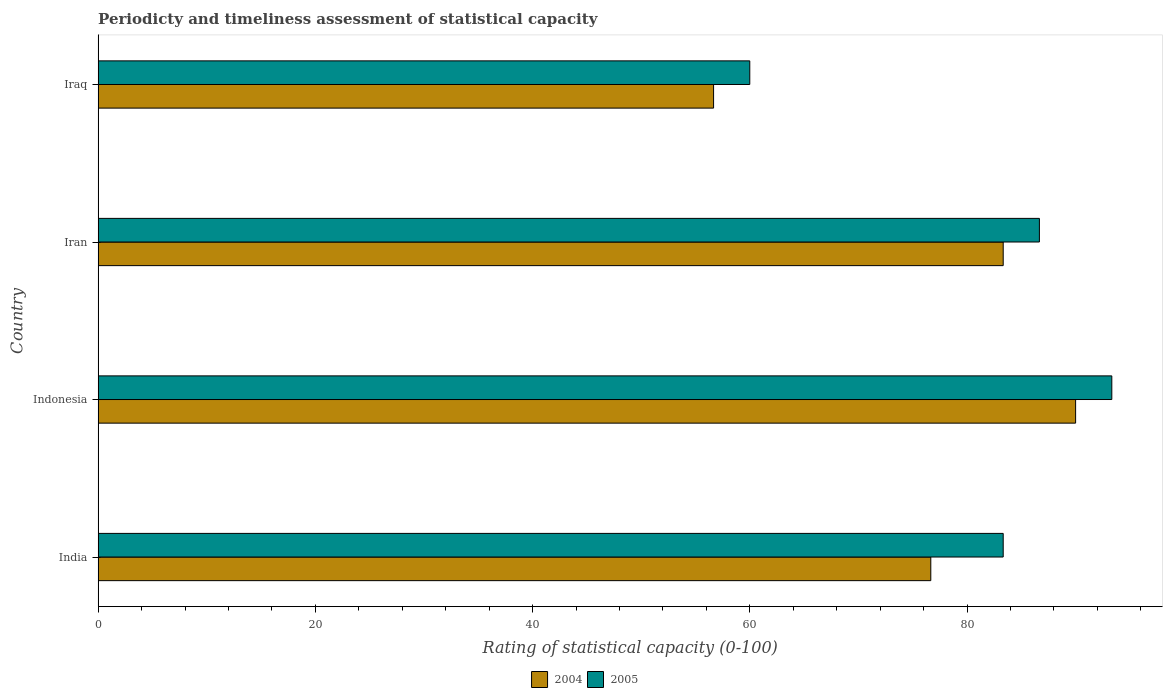How many groups of bars are there?
Your response must be concise. 4. Are the number of bars per tick equal to the number of legend labels?
Give a very brief answer. Yes. What is the label of the 2nd group of bars from the top?
Provide a succinct answer. Iran. In how many cases, is the number of bars for a given country not equal to the number of legend labels?
Offer a terse response. 0. What is the rating of statistical capacity in 2004 in India?
Provide a succinct answer. 76.67. In which country was the rating of statistical capacity in 2004 minimum?
Your answer should be very brief. Iraq. What is the total rating of statistical capacity in 2004 in the graph?
Provide a short and direct response. 306.67. What is the difference between the rating of statistical capacity in 2004 in India and that in Iran?
Your answer should be compact. -6.67. What is the average rating of statistical capacity in 2004 per country?
Give a very brief answer. 76.67. What is the difference between the rating of statistical capacity in 2004 and rating of statistical capacity in 2005 in Iraq?
Your answer should be compact. -3.33. In how many countries, is the rating of statistical capacity in 2004 greater than 80 ?
Provide a succinct answer. 2. What is the ratio of the rating of statistical capacity in 2005 in Indonesia to that in Iraq?
Offer a very short reply. 1.56. Is the rating of statistical capacity in 2005 in India less than that in Iraq?
Your answer should be compact. No. Is the difference between the rating of statistical capacity in 2004 in Iran and Iraq greater than the difference between the rating of statistical capacity in 2005 in Iran and Iraq?
Your answer should be compact. No. What is the difference between the highest and the second highest rating of statistical capacity in 2005?
Ensure brevity in your answer.  6.67. What is the difference between the highest and the lowest rating of statistical capacity in 2005?
Your answer should be very brief. 33.33. Is the sum of the rating of statistical capacity in 2004 in India and Iran greater than the maximum rating of statistical capacity in 2005 across all countries?
Your response must be concise. Yes. What does the 1st bar from the bottom in India represents?
Provide a short and direct response. 2004. Are all the bars in the graph horizontal?
Give a very brief answer. Yes. How many countries are there in the graph?
Provide a short and direct response. 4. What is the difference between two consecutive major ticks on the X-axis?
Offer a very short reply. 20. Are the values on the major ticks of X-axis written in scientific E-notation?
Your response must be concise. No. Does the graph contain grids?
Your answer should be very brief. No. Where does the legend appear in the graph?
Ensure brevity in your answer.  Bottom center. How are the legend labels stacked?
Provide a short and direct response. Horizontal. What is the title of the graph?
Offer a terse response. Periodicty and timeliness assessment of statistical capacity. What is the label or title of the X-axis?
Provide a succinct answer. Rating of statistical capacity (0-100). What is the label or title of the Y-axis?
Ensure brevity in your answer.  Country. What is the Rating of statistical capacity (0-100) in 2004 in India?
Keep it short and to the point. 76.67. What is the Rating of statistical capacity (0-100) of 2005 in India?
Offer a terse response. 83.33. What is the Rating of statistical capacity (0-100) of 2005 in Indonesia?
Provide a short and direct response. 93.33. What is the Rating of statistical capacity (0-100) in 2004 in Iran?
Provide a short and direct response. 83.33. What is the Rating of statistical capacity (0-100) of 2005 in Iran?
Make the answer very short. 86.67. What is the Rating of statistical capacity (0-100) in 2004 in Iraq?
Your answer should be compact. 56.67. What is the Rating of statistical capacity (0-100) in 2005 in Iraq?
Make the answer very short. 60. Across all countries, what is the maximum Rating of statistical capacity (0-100) of 2004?
Ensure brevity in your answer.  90. Across all countries, what is the maximum Rating of statistical capacity (0-100) of 2005?
Provide a short and direct response. 93.33. Across all countries, what is the minimum Rating of statistical capacity (0-100) of 2004?
Make the answer very short. 56.67. Across all countries, what is the minimum Rating of statistical capacity (0-100) of 2005?
Give a very brief answer. 60. What is the total Rating of statistical capacity (0-100) of 2004 in the graph?
Offer a very short reply. 306.67. What is the total Rating of statistical capacity (0-100) of 2005 in the graph?
Provide a short and direct response. 323.33. What is the difference between the Rating of statistical capacity (0-100) in 2004 in India and that in Indonesia?
Your response must be concise. -13.33. What is the difference between the Rating of statistical capacity (0-100) of 2005 in India and that in Indonesia?
Make the answer very short. -10. What is the difference between the Rating of statistical capacity (0-100) of 2004 in India and that in Iran?
Make the answer very short. -6.67. What is the difference between the Rating of statistical capacity (0-100) in 2004 in India and that in Iraq?
Offer a terse response. 20. What is the difference between the Rating of statistical capacity (0-100) of 2005 in India and that in Iraq?
Provide a short and direct response. 23.33. What is the difference between the Rating of statistical capacity (0-100) in 2005 in Indonesia and that in Iran?
Make the answer very short. 6.67. What is the difference between the Rating of statistical capacity (0-100) in 2004 in Indonesia and that in Iraq?
Give a very brief answer. 33.33. What is the difference between the Rating of statistical capacity (0-100) of 2005 in Indonesia and that in Iraq?
Offer a terse response. 33.33. What is the difference between the Rating of statistical capacity (0-100) of 2004 in Iran and that in Iraq?
Your answer should be very brief. 26.67. What is the difference between the Rating of statistical capacity (0-100) of 2005 in Iran and that in Iraq?
Offer a very short reply. 26.67. What is the difference between the Rating of statistical capacity (0-100) in 2004 in India and the Rating of statistical capacity (0-100) in 2005 in Indonesia?
Your answer should be compact. -16.67. What is the difference between the Rating of statistical capacity (0-100) in 2004 in India and the Rating of statistical capacity (0-100) in 2005 in Iraq?
Your answer should be compact. 16.67. What is the difference between the Rating of statistical capacity (0-100) of 2004 in Indonesia and the Rating of statistical capacity (0-100) of 2005 in Iran?
Your answer should be compact. 3.33. What is the difference between the Rating of statistical capacity (0-100) in 2004 in Iran and the Rating of statistical capacity (0-100) in 2005 in Iraq?
Make the answer very short. 23.33. What is the average Rating of statistical capacity (0-100) in 2004 per country?
Offer a very short reply. 76.67. What is the average Rating of statistical capacity (0-100) in 2005 per country?
Offer a very short reply. 80.83. What is the difference between the Rating of statistical capacity (0-100) of 2004 and Rating of statistical capacity (0-100) of 2005 in India?
Give a very brief answer. -6.67. What is the difference between the Rating of statistical capacity (0-100) in 2004 and Rating of statistical capacity (0-100) in 2005 in Indonesia?
Ensure brevity in your answer.  -3.33. What is the ratio of the Rating of statistical capacity (0-100) in 2004 in India to that in Indonesia?
Keep it short and to the point. 0.85. What is the ratio of the Rating of statistical capacity (0-100) in 2005 in India to that in Indonesia?
Your answer should be compact. 0.89. What is the ratio of the Rating of statistical capacity (0-100) in 2005 in India to that in Iran?
Ensure brevity in your answer.  0.96. What is the ratio of the Rating of statistical capacity (0-100) in 2004 in India to that in Iraq?
Give a very brief answer. 1.35. What is the ratio of the Rating of statistical capacity (0-100) in 2005 in India to that in Iraq?
Make the answer very short. 1.39. What is the ratio of the Rating of statistical capacity (0-100) in 2004 in Indonesia to that in Iran?
Make the answer very short. 1.08. What is the ratio of the Rating of statistical capacity (0-100) in 2005 in Indonesia to that in Iran?
Provide a succinct answer. 1.08. What is the ratio of the Rating of statistical capacity (0-100) in 2004 in Indonesia to that in Iraq?
Your answer should be compact. 1.59. What is the ratio of the Rating of statistical capacity (0-100) in 2005 in Indonesia to that in Iraq?
Offer a very short reply. 1.56. What is the ratio of the Rating of statistical capacity (0-100) in 2004 in Iran to that in Iraq?
Offer a very short reply. 1.47. What is the ratio of the Rating of statistical capacity (0-100) of 2005 in Iran to that in Iraq?
Keep it short and to the point. 1.44. What is the difference between the highest and the second highest Rating of statistical capacity (0-100) in 2004?
Offer a very short reply. 6.67. What is the difference between the highest and the second highest Rating of statistical capacity (0-100) of 2005?
Ensure brevity in your answer.  6.67. What is the difference between the highest and the lowest Rating of statistical capacity (0-100) of 2004?
Offer a terse response. 33.33. What is the difference between the highest and the lowest Rating of statistical capacity (0-100) of 2005?
Keep it short and to the point. 33.33. 